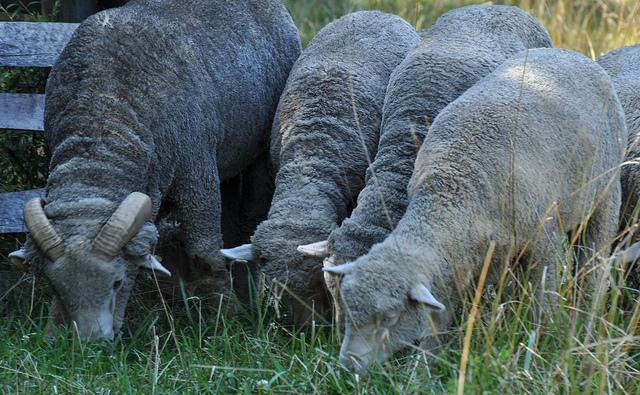A fleece is a kind of hair getting from which mammal? Please explain your reasoning. sheep. Shorn sheep wool is the source of fleece. 